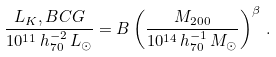Convert formula to latex. <formula><loc_0><loc_0><loc_500><loc_500>\frac { L _ { K } , B C G } { 1 0 ^ { 1 1 } \, h _ { 7 0 } ^ { - 2 } \, L _ { \odot } } = B \left ( \frac { M _ { 2 0 0 } } { 1 0 ^ { 1 4 } \, h _ { 7 0 } ^ { - 1 } \, M _ { \odot } } \right ) ^ { \beta } \, .</formula> 